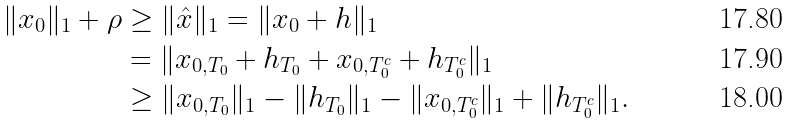<formula> <loc_0><loc_0><loc_500><loc_500>\| x _ { 0 } \| _ { 1 } + \rho & \geq \| \hat { x } \| _ { 1 } = \| x _ { 0 } + h \| _ { 1 } \\ & = \| x _ { 0 , T _ { 0 } } + h _ { T _ { 0 } } + x _ { 0 , T _ { 0 } ^ { c } } + h _ { T _ { 0 } ^ { c } } \| _ { 1 } \\ & \geq \| x _ { 0 , T _ { 0 } } \| _ { 1 } - \| h _ { T _ { 0 } } \| _ { 1 } - \| x _ { 0 , T _ { 0 } ^ { c } } \| _ { 1 } + \| h _ { T _ { 0 } ^ { c } } \| _ { 1 } .</formula> 